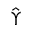Convert formula to latex. <formula><loc_0><loc_0><loc_500><loc_500>\hat { \Upsilon }</formula> 